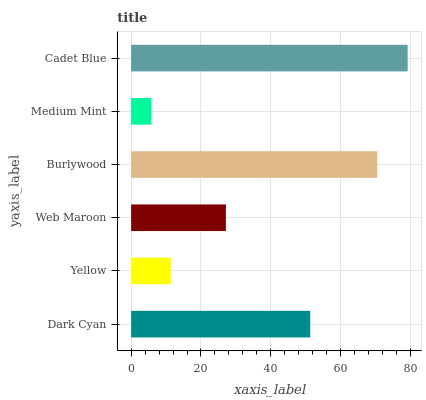Is Medium Mint the minimum?
Answer yes or no. Yes. Is Cadet Blue the maximum?
Answer yes or no. Yes. Is Yellow the minimum?
Answer yes or no. No. Is Yellow the maximum?
Answer yes or no. No. Is Dark Cyan greater than Yellow?
Answer yes or no. Yes. Is Yellow less than Dark Cyan?
Answer yes or no. Yes. Is Yellow greater than Dark Cyan?
Answer yes or no. No. Is Dark Cyan less than Yellow?
Answer yes or no. No. Is Dark Cyan the high median?
Answer yes or no. Yes. Is Web Maroon the low median?
Answer yes or no. Yes. Is Cadet Blue the high median?
Answer yes or no. No. Is Dark Cyan the low median?
Answer yes or no. No. 